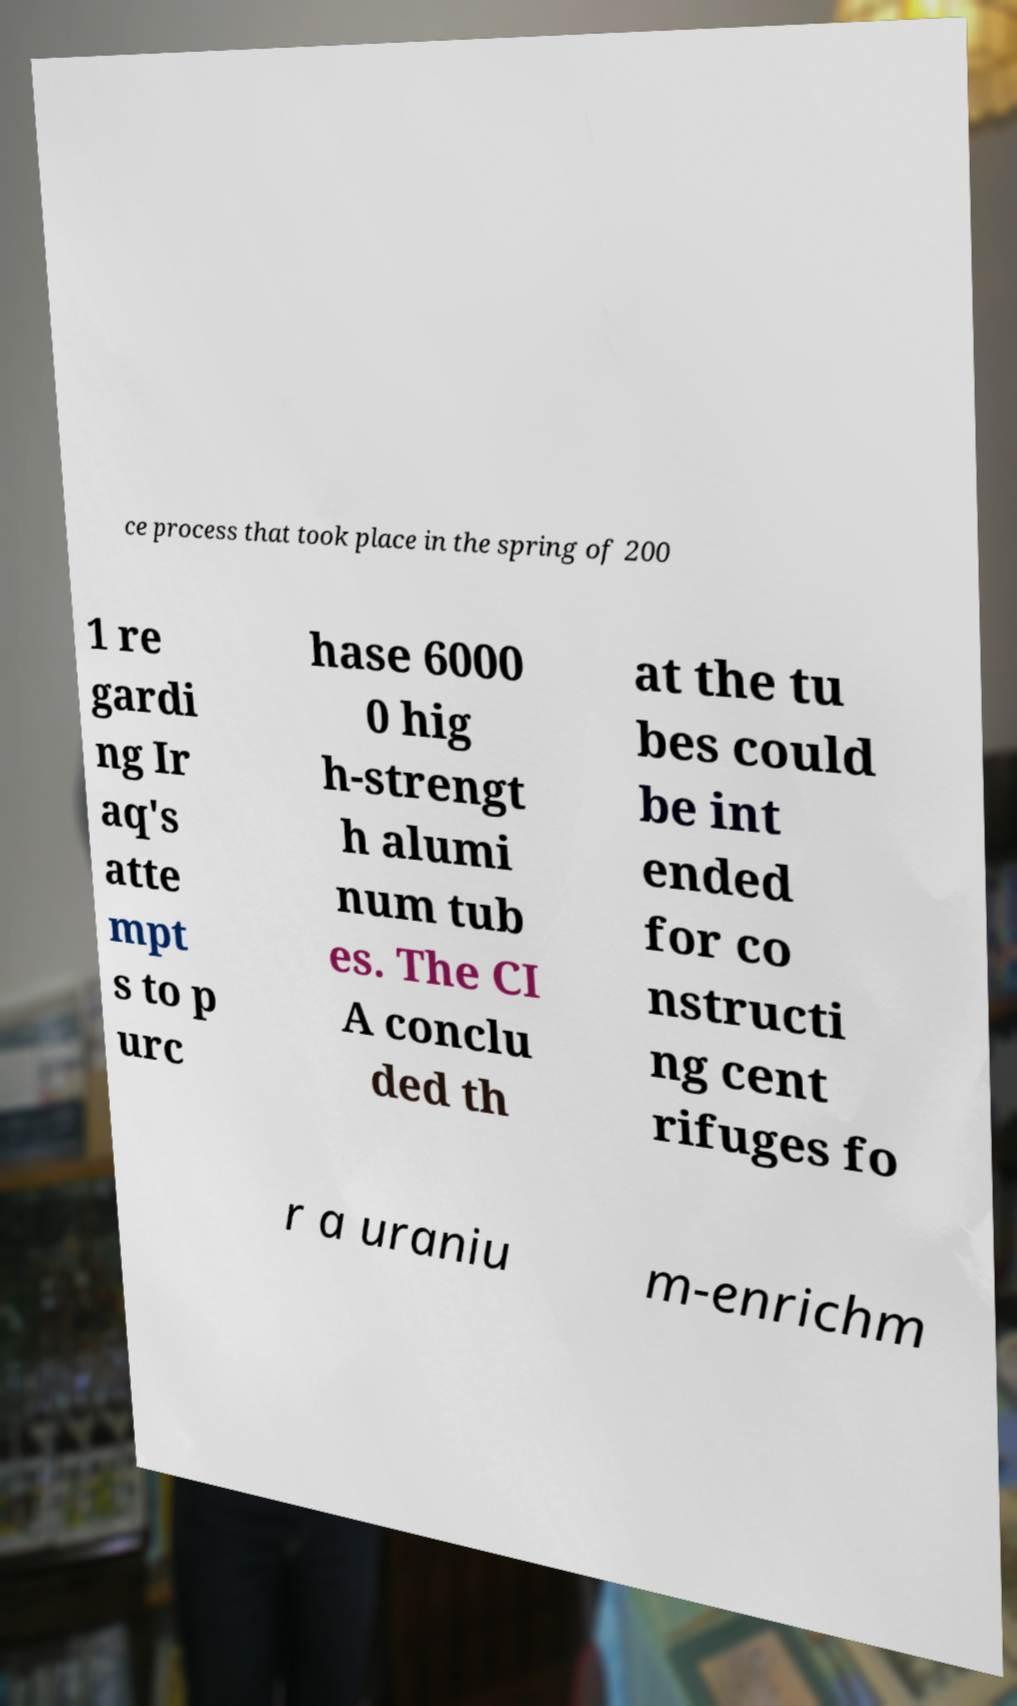Could you assist in decoding the text presented in this image and type it out clearly? ce process that took place in the spring of 200 1 re gardi ng Ir aq's atte mpt s to p urc hase 6000 0 hig h-strengt h alumi num tub es. The CI A conclu ded th at the tu bes could be int ended for co nstructi ng cent rifuges fo r a uraniu m-enrichm 